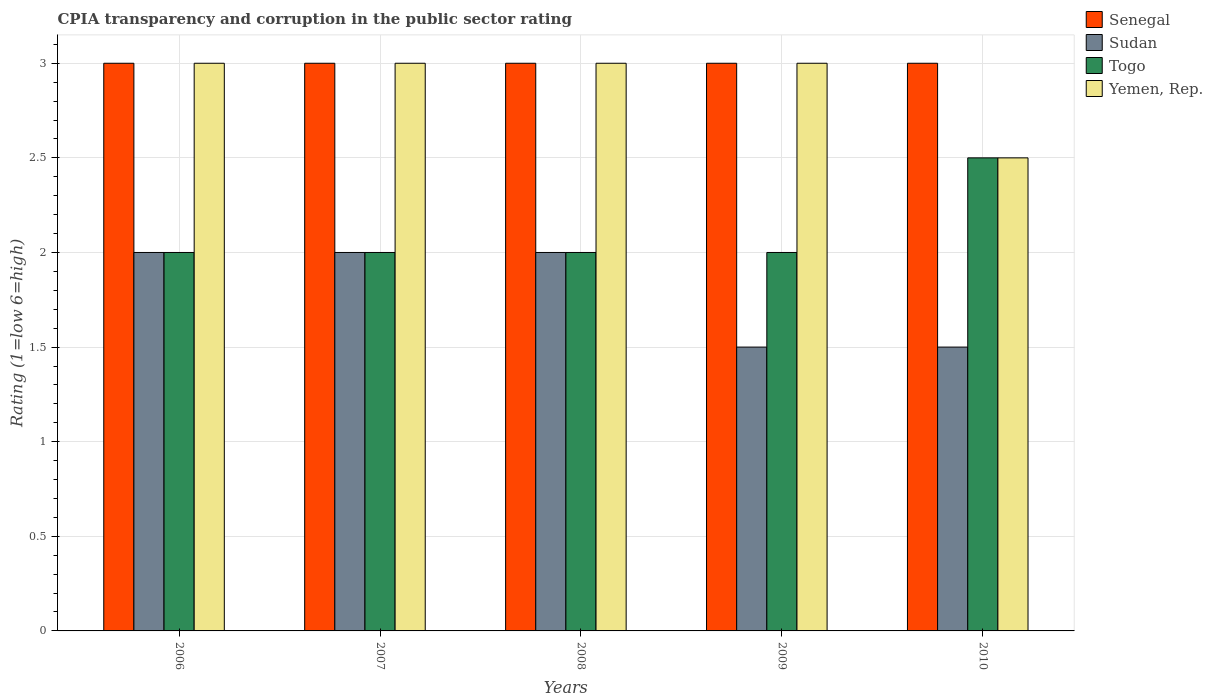How many groups of bars are there?
Give a very brief answer. 5. Are the number of bars on each tick of the X-axis equal?
Offer a very short reply. Yes. Across all years, what is the maximum CPIA rating in Togo?
Make the answer very short. 2.5. In which year was the CPIA rating in Sudan maximum?
Make the answer very short. 2006. What is the difference between the CPIA rating in Togo in 2007 and that in 2009?
Provide a succinct answer. 0. What is the difference between the CPIA rating in Yemen, Rep. in 2007 and the CPIA rating in Sudan in 2008?
Make the answer very short. 1. In how many years, is the CPIA rating in Senegal greater than 1.2?
Keep it short and to the point. 5. What is the ratio of the CPIA rating in Togo in 2006 to that in 2007?
Offer a very short reply. 1. Is the difference between the CPIA rating in Togo in 2007 and 2010 greater than the difference between the CPIA rating in Sudan in 2007 and 2010?
Give a very brief answer. No. What is the difference between the highest and the lowest CPIA rating in Senegal?
Provide a succinct answer. 0. In how many years, is the CPIA rating in Senegal greater than the average CPIA rating in Senegal taken over all years?
Offer a very short reply. 0. What does the 1st bar from the left in 2006 represents?
Your response must be concise. Senegal. What does the 1st bar from the right in 2006 represents?
Keep it short and to the point. Yemen, Rep. How many years are there in the graph?
Your answer should be very brief. 5. What is the difference between two consecutive major ticks on the Y-axis?
Your answer should be very brief. 0.5. Does the graph contain any zero values?
Provide a succinct answer. No. Does the graph contain grids?
Make the answer very short. Yes. Where does the legend appear in the graph?
Offer a terse response. Top right. How many legend labels are there?
Provide a short and direct response. 4. How are the legend labels stacked?
Ensure brevity in your answer.  Vertical. What is the title of the graph?
Offer a terse response. CPIA transparency and corruption in the public sector rating. Does "Tanzania" appear as one of the legend labels in the graph?
Provide a succinct answer. No. What is the label or title of the X-axis?
Keep it short and to the point. Years. What is the label or title of the Y-axis?
Provide a succinct answer. Rating (1=low 6=high). What is the Rating (1=low 6=high) in Senegal in 2006?
Offer a very short reply. 3. What is the Rating (1=low 6=high) in Sudan in 2006?
Make the answer very short. 2. What is the Rating (1=low 6=high) of Senegal in 2007?
Provide a succinct answer. 3. What is the Rating (1=low 6=high) of Sudan in 2007?
Your answer should be compact. 2. What is the Rating (1=low 6=high) in Togo in 2007?
Make the answer very short. 2. What is the Rating (1=low 6=high) in Senegal in 2008?
Your answer should be compact. 3. What is the Rating (1=low 6=high) in Togo in 2008?
Ensure brevity in your answer.  2. What is the Rating (1=low 6=high) of Sudan in 2009?
Provide a succinct answer. 1.5. What is the Rating (1=low 6=high) of Yemen, Rep. in 2009?
Offer a terse response. 3. What is the Rating (1=low 6=high) of Sudan in 2010?
Your response must be concise. 1.5. What is the Rating (1=low 6=high) of Togo in 2010?
Make the answer very short. 2.5. Across all years, what is the maximum Rating (1=low 6=high) in Senegal?
Ensure brevity in your answer.  3. Across all years, what is the maximum Rating (1=low 6=high) of Togo?
Give a very brief answer. 2.5. Across all years, what is the minimum Rating (1=low 6=high) of Yemen, Rep.?
Offer a very short reply. 2.5. What is the total Rating (1=low 6=high) in Togo in the graph?
Your answer should be very brief. 10.5. What is the difference between the Rating (1=low 6=high) of Senegal in 2006 and that in 2007?
Provide a short and direct response. 0. What is the difference between the Rating (1=low 6=high) of Sudan in 2006 and that in 2007?
Give a very brief answer. 0. What is the difference between the Rating (1=low 6=high) of Togo in 2006 and that in 2007?
Ensure brevity in your answer.  0. What is the difference between the Rating (1=low 6=high) of Yemen, Rep. in 2006 and that in 2007?
Your answer should be compact. 0. What is the difference between the Rating (1=low 6=high) of Senegal in 2006 and that in 2008?
Keep it short and to the point. 0. What is the difference between the Rating (1=low 6=high) of Togo in 2006 and that in 2008?
Give a very brief answer. 0. What is the difference between the Rating (1=low 6=high) in Senegal in 2006 and that in 2009?
Your answer should be compact. 0. What is the difference between the Rating (1=low 6=high) in Senegal in 2006 and that in 2010?
Your response must be concise. 0. What is the difference between the Rating (1=low 6=high) in Sudan in 2006 and that in 2010?
Provide a succinct answer. 0.5. What is the difference between the Rating (1=low 6=high) of Togo in 2006 and that in 2010?
Your response must be concise. -0.5. What is the difference between the Rating (1=low 6=high) in Sudan in 2007 and that in 2008?
Your response must be concise. 0. What is the difference between the Rating (1=low 6=high) of Togo in 2007 and that in 2008?
Ensure brevity in your answer.  0. What is the difference between the Rating (1=low 6=high) in Yemen, Rep. in 2007 and that in 2008?
Your answer should be very brief. 0. What is the difference between the Rating (1=low 6=high) of Senegal in 2007 and that in 2009?
Your response must be concise. 0. What is the difference between the Rating (1=low 6=high) of Yemen, Rep. in 2007 and that in 2009?
Ensure brevity in your answer.  0. What is the difference between the Rating (1=low 6=high) of Senegal in 2007 and that in 2010?
Provide a succinct answer. 0. What is the difference between the Rating (1=low 6=high) in Sudan in 2007 and that in 2010?
Your answer should be compact. 0.5. What is the difference between the Rating (1=low 6=high) of Togo in 2007 and that in 2010?
Provide a succinct answer. -0.5. What is the difference between the Rating (1=low 6=high) in Sudan in 2008 and that in 2009?
Give a very brief answer. 0.5. What is the difference between the Rating (1=low 6=high) of Togo in 2008 and that in 2009?
Give a very brief answer. 0. What is the difference between the Rating (1=low 6=high) in Yemen, Rep. in 2008 and that in 2009?
Your answer should be very brief. 0. What is the difference between the Rating (1=low 6=high) in Sudan in 2008 and that in 2010?
Provide a succinct answer. 0.5. What is the difference between the Rating (1=low 6=high) of Togo in 2009 and that in 2010?
Provide a succinct answer. -0.5. What is the difference between the Rating (1=low 6=high) in Yemen, Rep. in 2009 and that in 2010?
Make the answer very short. 0.5. What is the difference between the Rating (1=low 6=high) in Senegal in 2006 and the Rating (1=low 6=high) in Togo in 2007?
Your answer should be compact. 1. What is the difference between the Rating (1=low 6=high) of Sudan in 2006 and the Rating (1=low 6=high) of Togo in 2007?
Provide a succinct answer. 0. What is the difference between the Rating (1=low 6=high) in Togo in 2006 and the Rating (1=low 6=high) in Yemen, Rep. in 2007?
Your answer should be compact. -1. What is the difference between the Rating (1=low 6=high) of Senegal in 2006 and the Rating (1=low 6=high) of Sudan in 2008?
Keep it short and to the point. 1. What is the difference between the Rating (1=low 6=high) of Senegal in 2006 and the Rating (1=low 6=high) of Togo in 2008?
Keep it short and to the point. 1. What is the difference between the Rating (1=low 6=high) of Senegal in 2006 and the Rating (1=low 6=high) of Yemen, Rep. in 2008?
Your answer should be very brief. 0. What is the difference between the Rating (1=low 6=high) in Sudan in 2006 and the Rating (1=low 6=high) in Yemen, Rep. in 2008?
Your response must be concise. -1. What is the difference between the Rating (1=low 6=high) of Togo in 2006 and the Rating (1=low 6=high) of Yemen, Rep. in 2008?
Offer a terse response. -1. What is the difference between the Rating (1=low 6=high) in Senegal in 2006 and the Rating (1=low 6=high) in Togo in 2009?
Your response must be concise. 1. What is the difference between the Rating (1=low 6=high) of Sudan in 2006 and the Rating (1=low 6=high) of Togo in 2009?
Your answer should be compact. 0. What is the difference between the Rating (1=low 6=high) in Sudan in 2006 and the Rating (1=low 6=high) in Yemen, Rep. in 2009?
Your response must be concise. -1. What is the difference between the Rating (1=low 6=high) in Senegal in 2006 and the Rating (1=low 6=high) in Sudan in 2010?
Your answer should be compact. 1.5. What is the difference between the Rating (1=low 6=high) in Togo in 2006 and the Rating (1=low 6=high) in Yemen, Rep. in 2010?
Keep it short and to the point. -0.5. What is the difference between the Rating (1=low 6=high) in Senegal in 2007 and the Rating (1=low 6=high) in Togo in 2008?
Offer a very short reply. 1. What is the difference between the Rating (1=low 6=high) in Senegal in 2007 and the Rating (1=low 6=high) in Sudan in 2009?
Provide a short and direct response. 1.5. What is the difference between the Rating (1=low 6=high) of Senegal in 2007 and the Rating (1=low 6=high) of Togo in 2009?
Ensure brevity in your answer.  1. What is the difference between the Rating (1=low 6=high) of Togo in 2007 and the Rating (1=low 6=high) of Yemen, Rep. in 2009?
Offer a terse response. -1. What is the difference between the Rating (1=low 6=high) in Senegal in 2007 and the Rating (1=low 6=high) in Togo in 2010?
Keep it short and to the point. 0.5. What is the difference between the Rating (1=low 6=high) in Sudan in 2007 and the Rating (1=low 6=high) in Yemen, Rep. in 2010?
Keep it short and to the point. -0.5. What is the difference between the Rating (1=low 6=high) of Senegal in 2008 and the Rating (1=low 6=high) of Yemen, Rep. in 2009?
Your answer should be compact. 0. What is the difference between the Rating (1=low 6=high) in Senegal in 2008 and the Rating (1=low 6=high) in Sudan in 2010?
Give a very brief answer. 1.5. What is the difference between the Rating (1=low 6=high) of Senegal in 2008 and the Rating (1=low 6=high) of Togo in 2010?
Your answer should be very brief. 0.5. What is the difference between the Rating (1=low 6=high) of Senegal in 2008 and the Rating (1=low 6=high) of Yemen, Rep. in 2010?
Make the answer very short. 0.5. What is the difference between the Rating (1=low 6=high) in Sudan in 2008 and the Rating (1=low 6=high) in Togo in 2010?
Provide a succinct answer. -0.5. What is the difference between the Rating (1=low 6=high) in Sudan in 2008 and the Rating (1=low 6=high) in Yemen, Rep. in 2010?
Offer a terse response. -0.5. What is the difference between the Rating (1=low 6=high) of Togo in 2008 and the Rating (1=low 6=high) of Yemen, Rep. in 2010?
Your answer should be compact. -0.5. What is the difference between the Rating (1=low 6=high) in Senegal in 2009 and the Rating (1=low 6=high) in Togo in 2010?
Your answer should be very brief. 0.5. What is the difference between the Rating (1=low 6=high) in Sudan in 2009 and the Rating (1=low 6=high) in Togo in 2010?
Offer a terse response. -1. In the year 2006, what is the difference between the Rating (1=low 6=high) in Senegal and Rating (1=low 6=high) in Sudan?
Offer a terse response. 1. In the year 2006, what is the difference between the Rating (1=low 6=high) in Senegal and Rating (1=low 6=high) in Yemen, Rep.?
Give a very brief answer. 0. In the year 2006, what is the difference between the Rating (1=low 6=high) of Sudan and Rating (1=low 6=high) of Togo?
Your response must be concise. 0. In the year 2006, what is the difference between the Rating (1=low 6=high) in Sudan and Rating (1=low 6=high) in Yemen, Rep.?
Your answer should be very brief. -1. In the year 2007, what is the difference between the Rating (1=low 6=high) in Senegal and Rating (1=low 6=high) in Togo?
Ensure brevity in your answer.  1. In the year 2007, what is the difference between the Rating (1=low 6=high) of Senegal and Rating (1=low 6=high) of Yemen, Rep.?
Offer a very short reply. 0. In the year 2007, what is the difference between the Rating (1=low 6=high) in Sudan and Rating (1=low 6=high) in Togo?
Provide a short and direct response. 0. In the year 2007, what is the difference between the Rating (1=low 6=high) of Togo and Rating (1=low 6=high) of Yemen, Rep.?
Keep it short and to the point. -1. In the year 2008, what is the difference between the Rating (1=low 6=high) of Senegal and Rating (1=low 6=high) of Sudan?
Your answer should be compact. 1. In the year 2008, what is the difference between the Rating (1=low 6=high) in Senegal and Rating (1=low 6=high) in Togo?
Your answer should be very brief. 1. In the year 2008, what is the difference between the Rating (1=low 6=high) of Senegal and Rating (1=low 6=high) of Yemen, Rep.?
Provide a succinct answer. 0. In the year 2008, what is the difference between the Rating (1=low 6=high) of Sudan and Rating (1=low 6=high) of Togo?
Provide a short and direct response. 0. In the year 2009, what is the difference between the Rating (1=low 6=high) of Senegal and Rating (1=low 6=high) of Sudan?
Your response must be concise. 1.5. In the year 2009, what is the difference between the Rating (1=low 6=high) of Togo and Rating (1=low 6=high) of Yemen, Rep.?
Ensure brevity in your answer.  -1. In the year 2010, what is the difference between the Rating (1=low 6=high) of Senegal and Rating (1=low 6=high) of Yemen, Rep.?
Offer a terse response. 0.5. In the year 2010, what is the difference between the Rating (1=low 6=high) in Sudan and Rating (1=low 6=high) in Yemen, Rep.?
Your answer should be compact. -1. What is the ratio of the Rating (1=low 6=high) of Senegal in 2006 to that in 2007?
Provide a succinct answer. 1. What is the ratio of the Rating (1=low 6=high) in Sudan in 2006 to that in 2007?
Keep it short and to the point. 1. What is the ratio of the Rating (1=low 6=high) in Yemen, Rep. in 2006 to that in 2007?
Provide a short and direct response. 1. What is the ratio of the Rating (1=low 6=high) of Togo in 2006 to that in 2008?
Make the answer very short. 1. What is the ratio of the Rating (1=low 6=high) of Yemen, Rep. in 2006 to that in 2009?
Your answer should be compact. 1. What is the ratio of the Rating (1=low 6=high) of Senegal in 2007 to that in 2008?
Provide a succinct answer. 1. What is the ratio of the Rating (1=low 6=high) in Yemen, Rep. in 2007 to that in 2008?
Offer a very short reply. 1. What is the ratio of the Rating (1=low 6=high) in Sudan in 2007 to that in 2009?
Offer a very short reply. 1.33. What is the ratio of the Rating (1=low 6=high) of Togo in 2007 to that in 2009?
Make the answer very short. 1. What is the ratio of the Rating (1=low 6=high) in Yemen, Rep. in 2007 to that in 2009?
Make the answer very short. 1. What is the ratio of the Rating (1=low 6=high) in Senegal in 2007 to that in 2010?
Keep it short and to the point. 1. What is the ratio of the Rating (1=low 6=high) of Sudan in 2007 to that in 2010?
Keep it short and to the point. 1.33. What is the ratio of the Rating (1=low 6=high) in Yemen, Rep. in 2007 to that in 2010?
Offer a terse response. 1.2. What is the ratio of the Rating (1=low 6=high) in Sudan in 2008 to that in 2009?
Provide a short and direct response. 1.33. What is the ratio of the Rating (1=low 6=high) of Senegal in 2008 to that in 2010?
Provide a short and direct response. 1. What is the ratio of the Rating (1=low 6=high) in Sudan in 2008 to that in 2010?
Provide a succinct answer. 1.33. What is the ratio of the Rating (1=low 6=high) in Togo in 2008 to that in 2010?
Your answer should be very brief. 0.8. What is the ratio of the Rating (1=low 6=high) in Yemen, Rep. in 2008 to that in 2010?
Your answer should be compact. 1.2. What is the ratio of the Rating (1=low 6=high) in Senegal in 2009 to that in 2010?
Offer a terse response. 1. What is the ratio of the Rating (1=low 6=high) in Yemen, Rep. in 2009 to that in 2010?
Give a very brief answer. 1.2. What is the difference between the highest and the lowest Rating (1=low 6=high) in Senegal?
Keep it short and to the point. 0. 